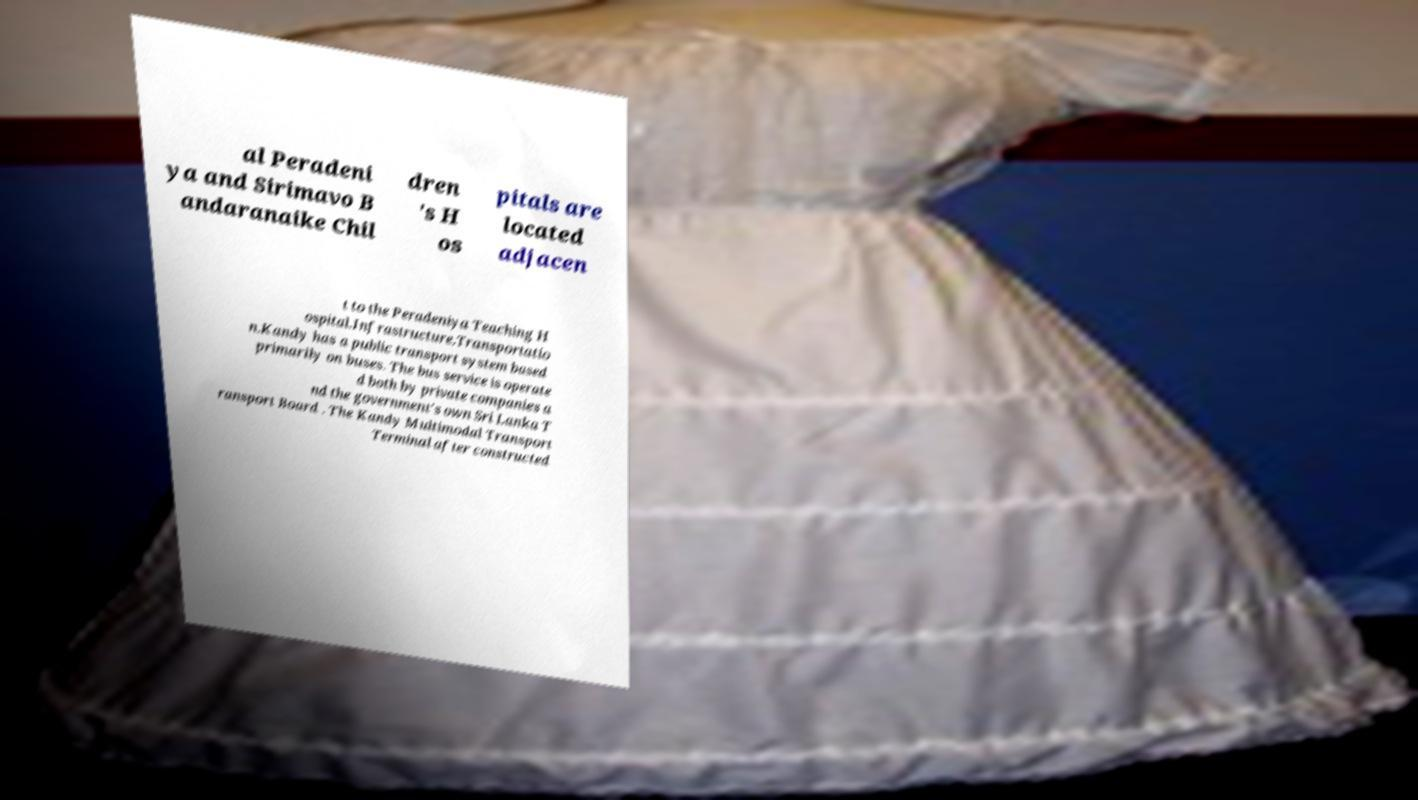I need the written content from this picture converted into text. Can you do that? al Peradeni ya and Sirimavo B andaranaike Chil dren 's H os pitals are located adjacen t to the Peradeniya Teaching H ospital.Infrastructure.Transportatio n.Kandy has a public transport system based primarily on buses. The bus service is operate d both by private companies a nd the government's own Sri Lanka T ransport Board . The Kandy Multimodal Transport Terminal after constructed 